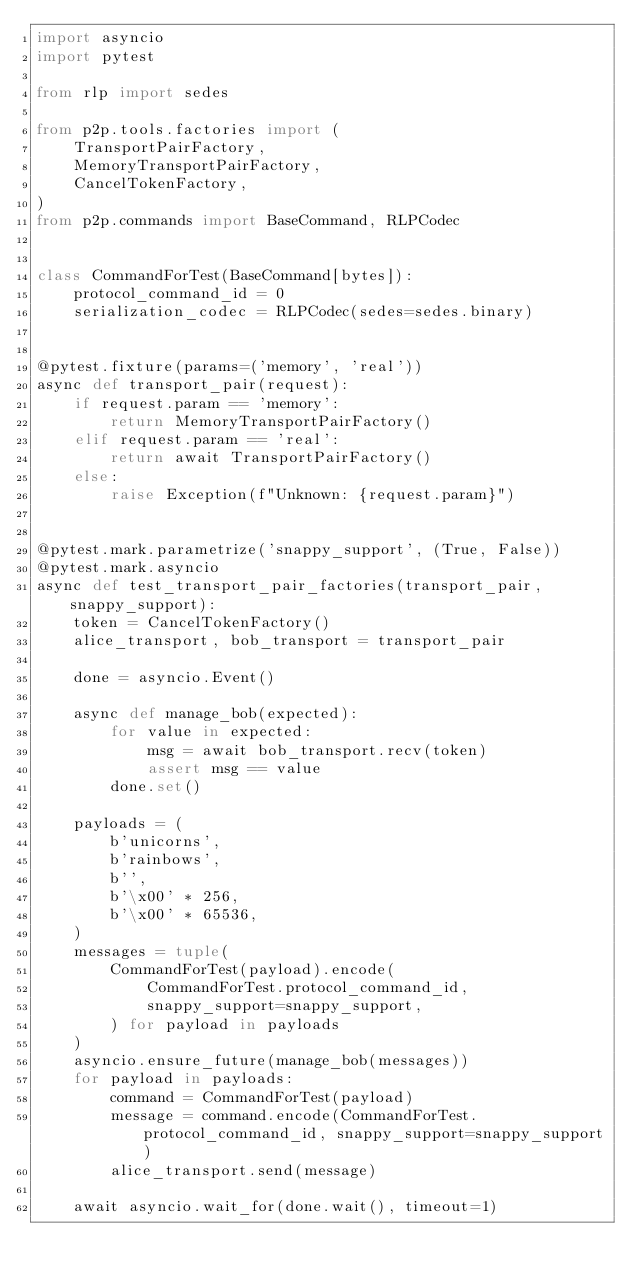Convert code to text. <code><loc_0><loc_0><loc_500><loc_500><_Python_>import asyncio
import pytest

from rlp import sedes

from p2p.tools.factories import (
    TransportPairFactory,
    MemoryTransportPairFactory,
    CancelTokenFactory,
)
from p2p.commands import BaseCommand, RLPCodec


class CommandForTest(BaseCommand[bytes]):
    protocol_command_id = 0
    serialization_codec = RLPCodec(sedes=sedes.binary)


@pytest.fixture(params=('memory', 'real'))
async def transport_pair(request):
    if request.param == 'memory':
        return MemoryTransportPairFactory()
    elif request.param == 'real':
        return await TransportPairFactory()
    else:
        raise Exception(f"Unknown: {request.param}")


@pytest.mark.parametrize('snappy_support', (True, False))
@pytest.mark.asyncio
async def test_transport_pair_factories(transport_pair, snappy_support):
    token = CancelTokenFactory()
    alice_transport, bob_transport = transport_pair

    done = asyncio.Event()

    async def manage_bob(expected):
        for value in expected:
            msg = await bob_transport.recv(token)
            assert msg == value
        done.set()

    payloads = (
        b'unicorns',
        b'rainbows',
        b'',
        b'\x00' * 256,
        b'\x00' * 65536,
    )
    messages = tuple(
        CommandForTest(payload).encode(
            CommandForTest.protocol_command_id,
            snappy_support=snappy_support,
        ) for payload in payloads
    )
    asyncio.ensure_future(manage_bob(messages))
    for payload in payloads:
        command = CommandForTest(payload)
        message = command.encode(CommandForTest.protocol_command_id, snappy_support=snappy_support)
        alice_transport.send(message)

    await asyncio.wait_for(done.wait(), timeout=1)
</code> 